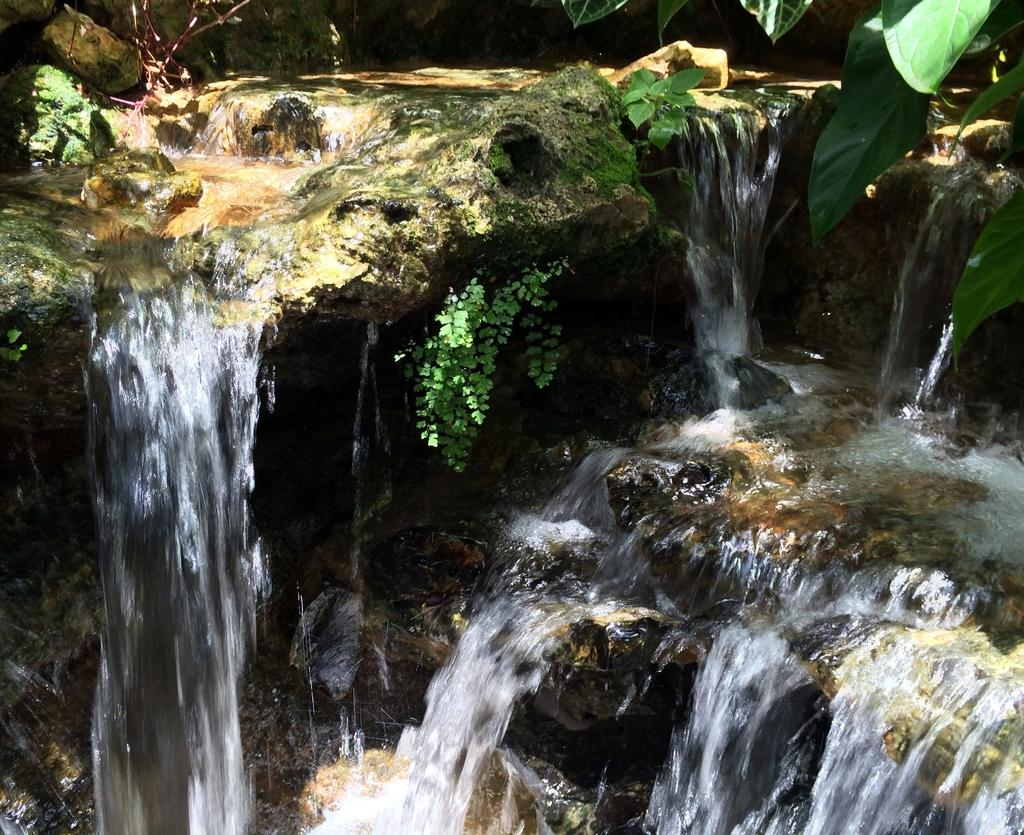What is happening in the image? There is water flowing in the image. What else can be seen in the image besides the water? There are plants in the image. Can you describe the plants in the image? Green leaves are visible in the top right-hand side of the image. How many sticks are being used by the goose in the image? There is no goose or sticks present in the image. 